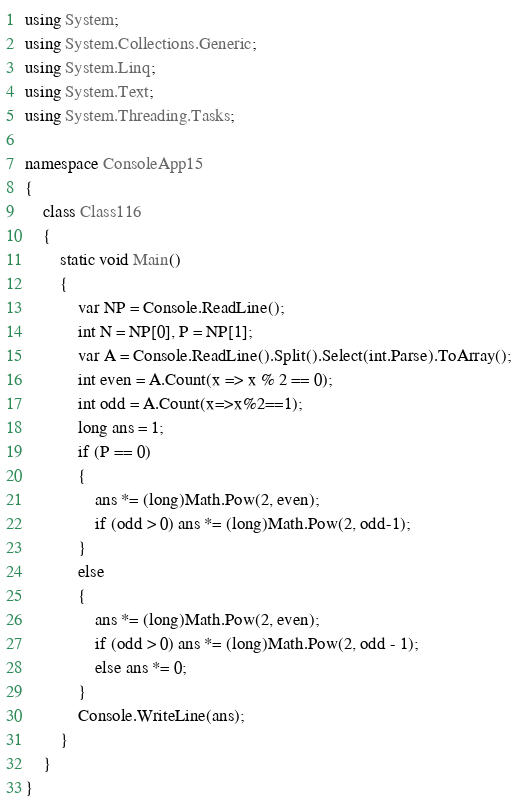Convert code to text. <code><loc_0><loc_0><loc_500><loc_500><_C#_>using System;
using System.Collections.Generic;
using System.Linq;
using System.Text;
using System.Threading.Tasks;

namespace ConsoleApp15
{
    class Class116
    {
        static void Main()
        {
            var NP = Console.ReadLine();
            int N = NP[0], P = NP[1];
            var A = Console.ReadLine().Split().Select(int.Parse).ToArray();
            int even = A.Count(x => x % 2 == 0);
            int odd = A.Count(x=>x%2==1);
            long ans = 1;
            if (P == 0)
            {
                ans *= (long)Math.Pow(2, even);
                if (odd > 0) ans *= (long)Math.Pow(2, odd-1);
            }
            else
            {
                ans *= (long)Math.Pow(2, even);
                if (odd > 0) ans *= (long)Math.Pow(2, odd - 1);
                else ans *= 0;
            }
            Console.WriteLine(ans);
        }
    }
}
</code> 